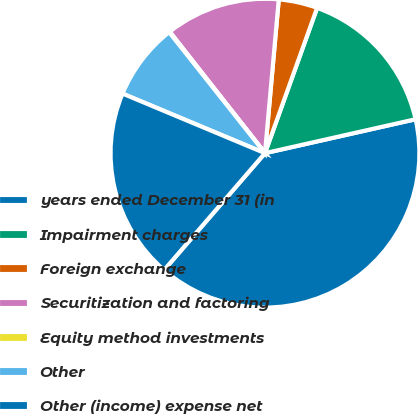<chart> <loc_0><loc_0><loc_500><loc_500><pie_chart><fcel>years ended December 31 (in<fcel>Impairment charges<fcel>Foreign exchange<fcel>Securitization and factoring<fcel>Equity method investments<fcel>Other<fcel>Other (income) expense net<nl><fcel>39.86%<fcel>15.99%<fcel>4.06%<fcel>12.01%<fcel>0.08%<fcel>8.03%<fcel>19.97%<nl></chart> 